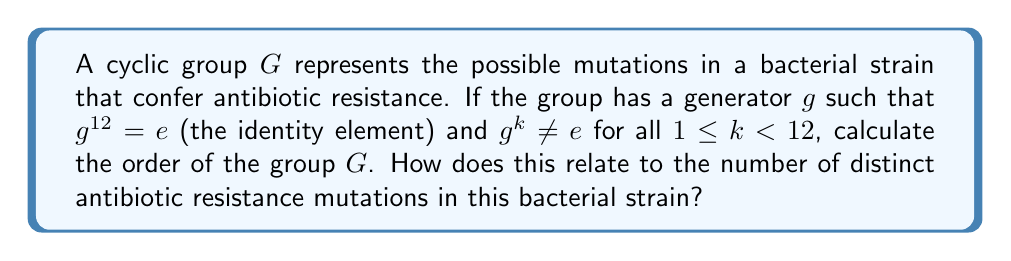What is the answer to this math problem? To solve this problem, we need to understand the properties of cyclic groups and their relation to antibiotic resistance mutations:

1) In a cyclic group, all elements can be generated by repeatedly applying the generator element $g$.

2) The order of a cyclic group is the smallest positive integer $n$ such that $g^n = e$, where $e$ is the identity element.

3) Given that $g^{12} = e$ and $g^k \neq e$ for all $1 \leq k < 12$, we can conclude that 12 is the smallest positive integer that satisfies this condition.

4) Therefore, the order of the group $G$ is 12.

In the context of antibiotic resistance mutations:

5) Each element of the group can represent a distinct mutation state of the bacterial strain.

6) The identity element $e$ represents the original, non-mutated state.

7) Each application of $g$ represents a single mutation event.

8) The cyclic nature of the group implies that after 12 mutations, the bacterial strain returns to a state equivalent to the original in terms of antibiotic resistance.

9) Therefore, there are 12 distinct antibiotic resistance mutation states in this bacterial strain, including the original non-mutated state.

This mathematical model provides a simplified representation of how antibiotic resistance mutations might occur in a cyclic pattern, which can be useful for predicting and understanding the development of resistance in bacterial populations.
Answer: The order of the cyclic group $G$ is 12, corresponding to 12 distinct antibiotic resistance mutation states in the bacterial strain. 